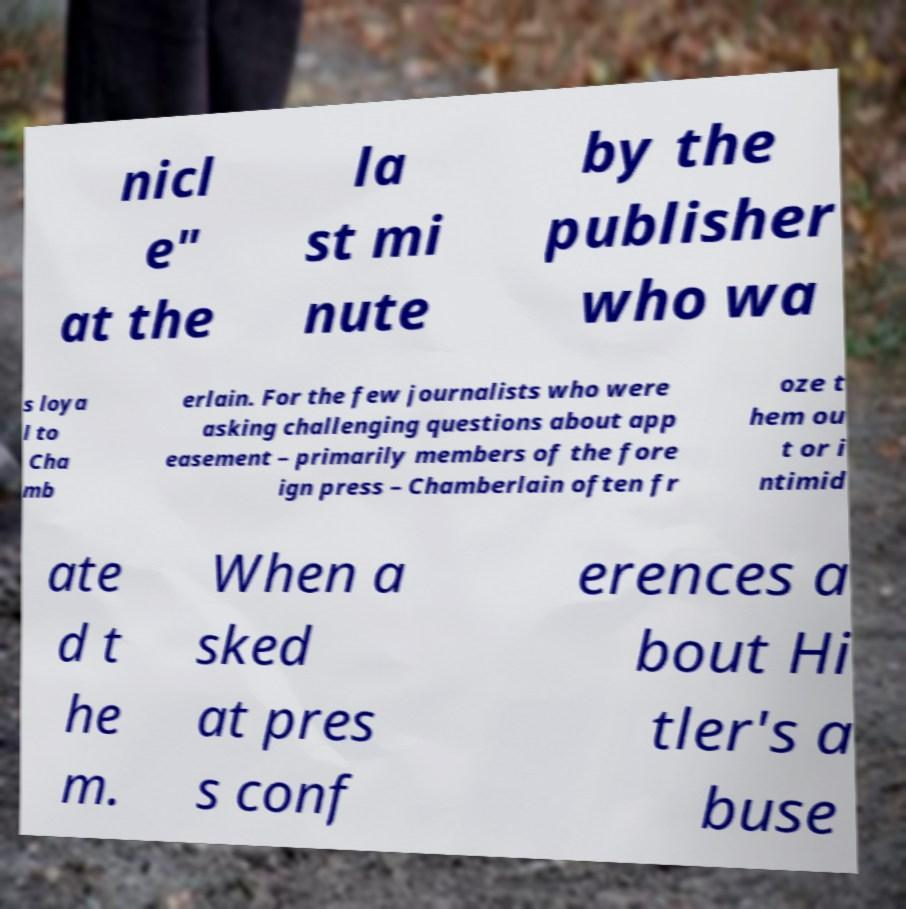I need the written content from this picture converted into text. Can you do that? nicl e" at the la st mi nute by the publisher who wa s loya l to Cha mb erlain. For the few journalists who were asking challenging questions about app easement – primarily members of the fore ign press – Chamberlain often fr oze t hem ou t or i ntimid ate d t he m. When a sked at pres s conf erences a bout Hi tler's a buse 